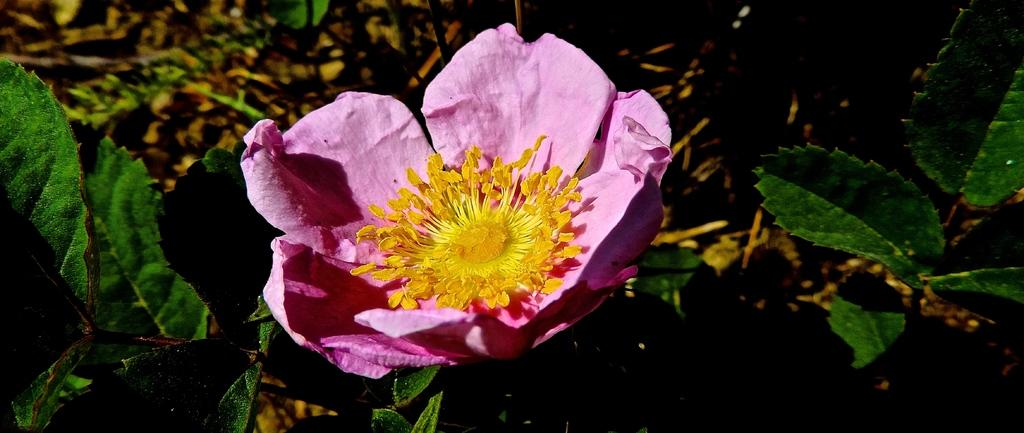What type of flower can be seen in the image? There is a pink flower in the image. Where is the flower located on the plant? The flower is on a plant. How is the plant positioned in the image? The plant is in the center of the image. What can be seen on both sides of the plant? There are leaves on the right side and the left side of the image. How many ducks are swimming in the pond in the image? There is no pond or duck present in the image; it features a pink flower on a plant. 